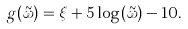Convert formula to latex. <formula><loc_0><loc_0><loc_500><loc_500>g ( \tilde { \omega } ) = \xi + 5 \log ( \tilde { \omega } ) - 1 0 .</formula> 